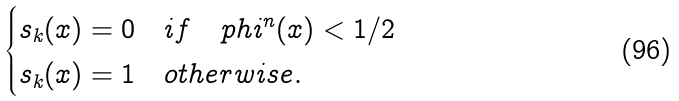<formula> <loc_0><loc_0><loc_500><loc_500>\begin{cases} s _ { k } ( x ) = 0 \quad i f \quad p h i ^ { n } ( x ) < 1 / 2 \\ s _ { k } ( x ) = 1 \quad o t h e r w i s e . \end{cases}</formula> 